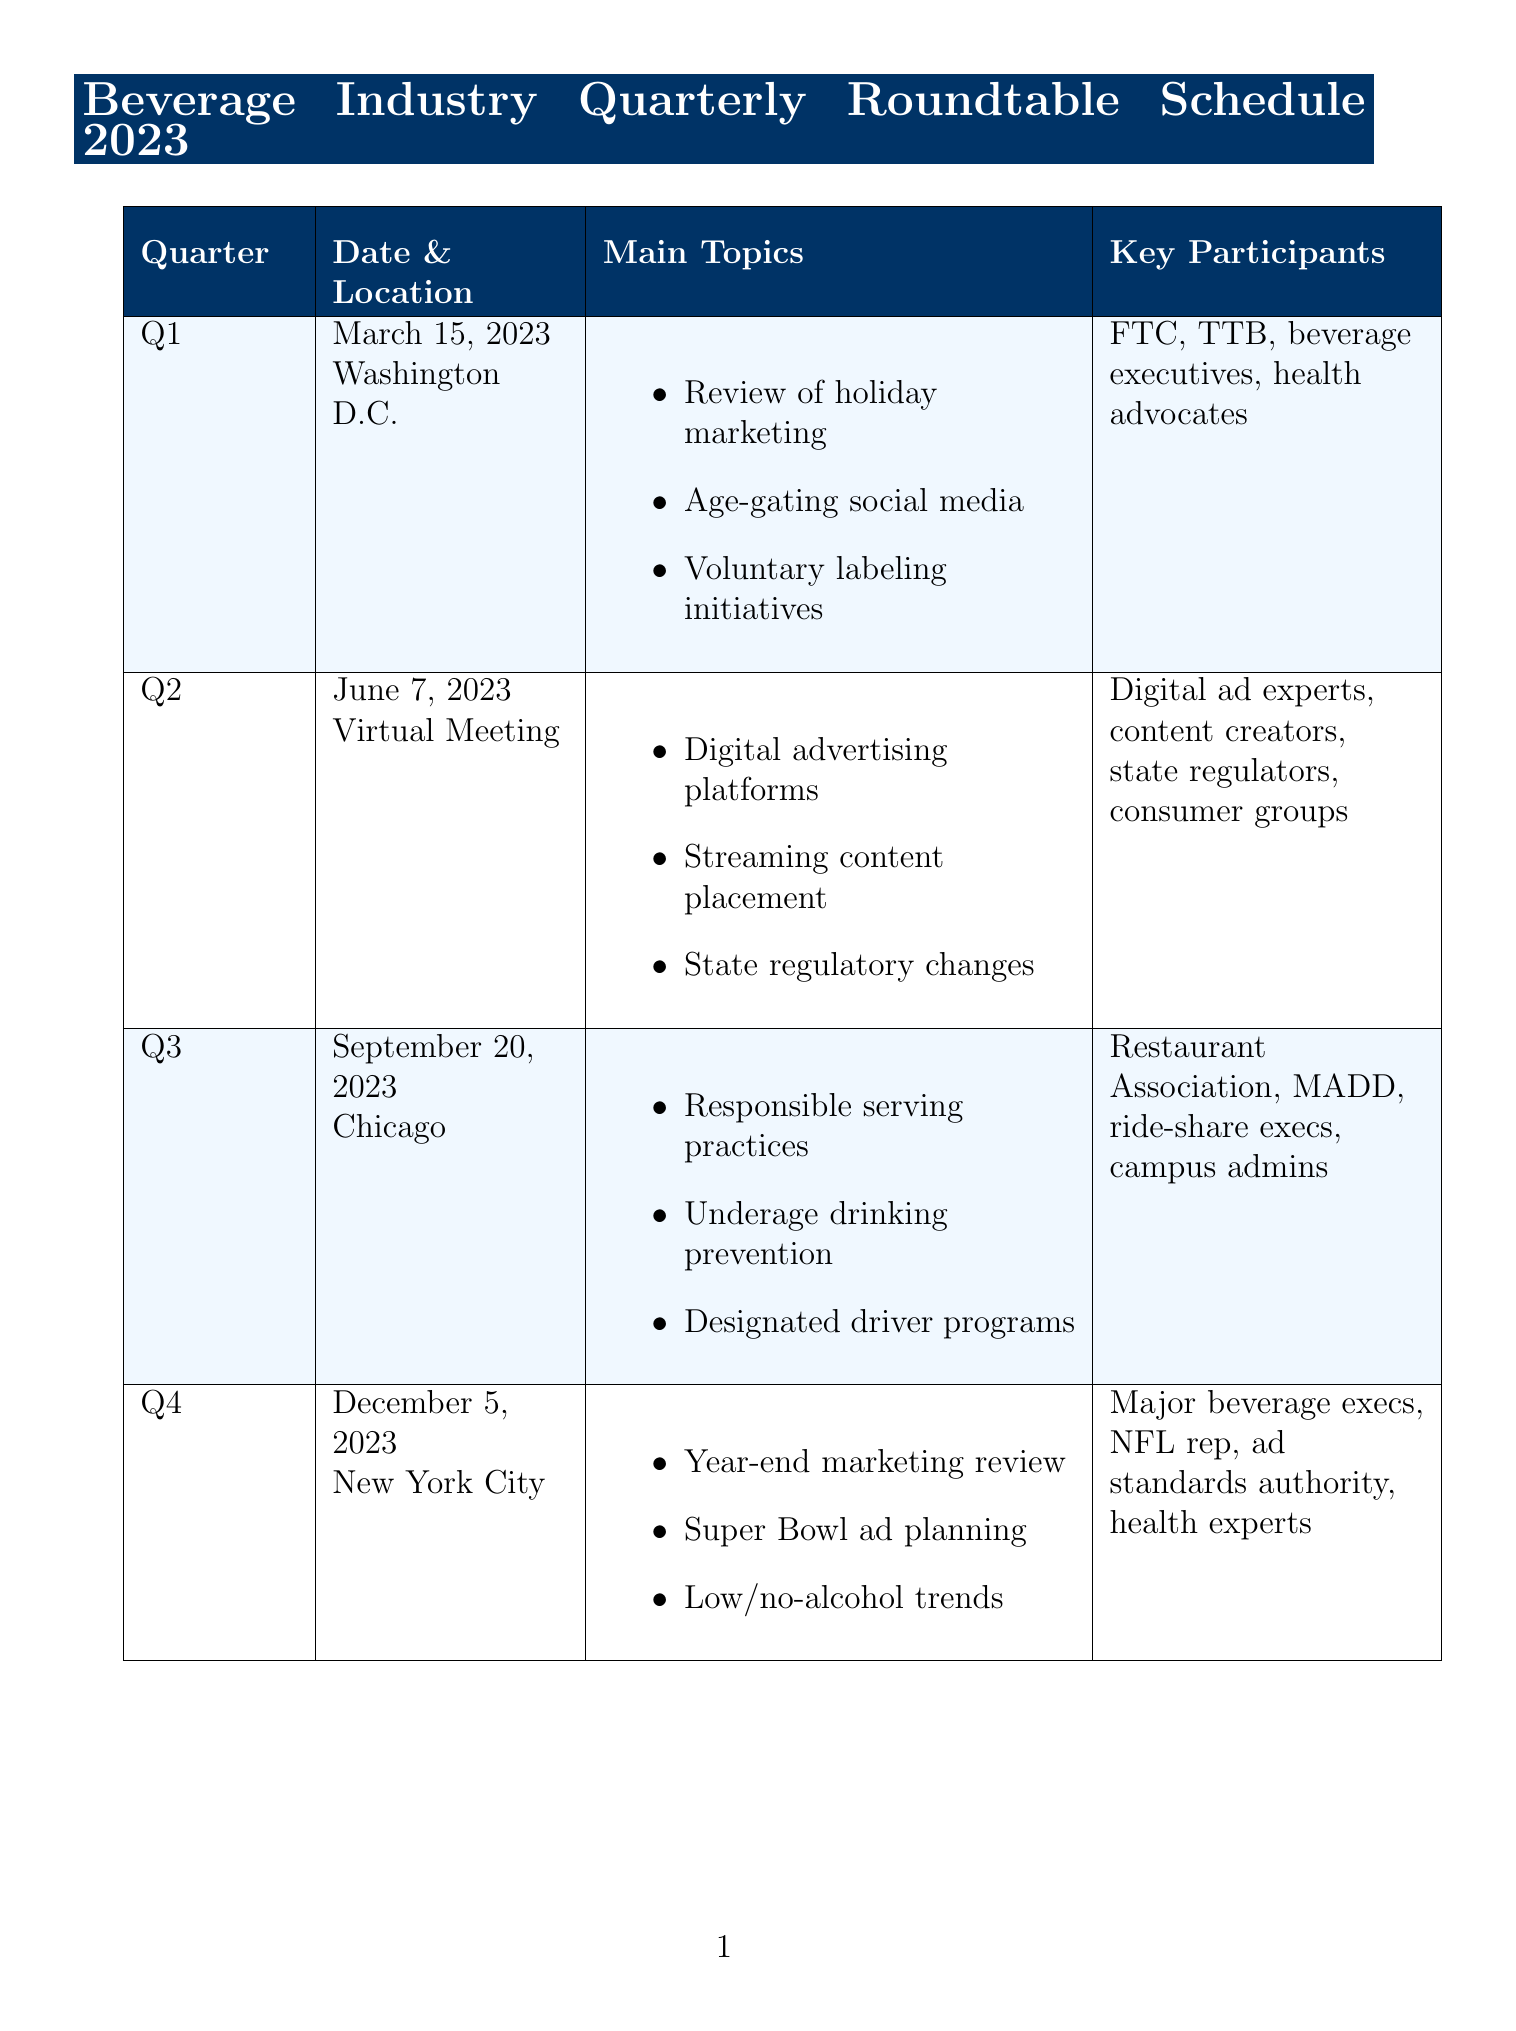What is the date of the Q1 meeting? The date of the Q1 meeting is explicitly mentioned in the document.
Answer: March 15, 2023 Where is the Q3 meeting located? The location of the Q3 meeting is provided in the schedule.
Answer: Chicago What are the main topics of the Q2 meeting? The main topics for Q2 are listed in the document.
Answer: Evaluation of new digital advertising platforms, Discussion on product placement in streaming content, Review of state-level regulatory changes Which organizations are represented as key participants in Q4? The document specifies key participants for the Q4 meeting.
Answer: Diageo, Anheuser-Busch, and Constellation Brands executives, NFL representative for alcohol sponsorships, Advertising Standards Authority members, Nutritionists and health experts What initiative focuses on underage drinking prevention? This initiative is described in the ongoing initiatives section of the document.
Answer: Responsibility.org Partnership How many quarterly meetings are scheduled for 2023? The number of quarterly meetings can be counted from the document.
Answer: Four What is the objective of the Smart Drinking Goals initiative? The key activities of this initiative highlight its objective within the document.
Answer: Industry-wide commitment to reduce harmful use of alcohol What action item is planned for Q1? The action items for each quarter are detailed in the schedule.
Answer: Draft updated social media guidelines What is a key activity of the Server Training Enhancement Program? The key activities of this program illustrate its purpose.
Answer: Updating curriculum to address new industry challenges 